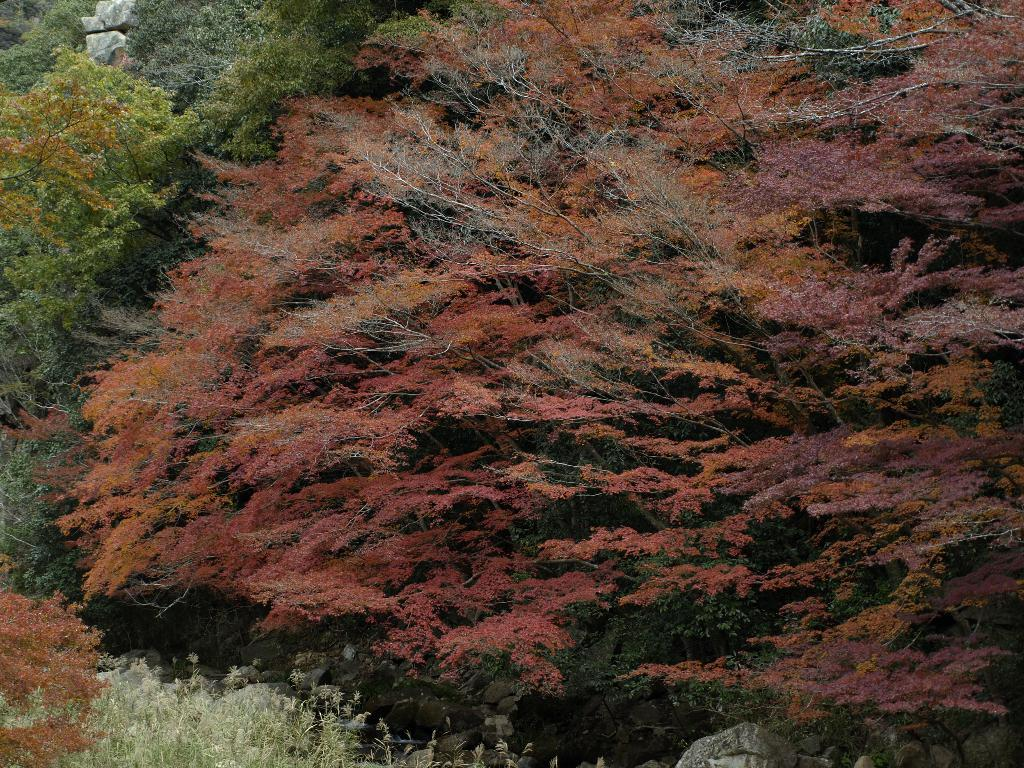What type of vegetation can be seen in the image? There are trees and plants in the image. Are there any other natural elements present in the image? Yes, there are rocks in the image. How many children are playing with the knife in the image? There are no children or knives present in the image. 